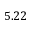<formula> <loc_0><loc_0><loc_500><loc_500>5 . 2 2</formula> 